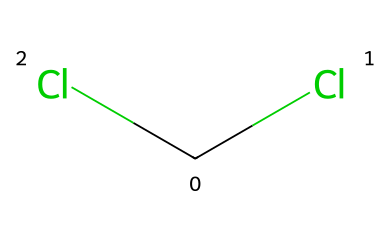How many chlorine atoms are present in the chemical? Inspecting the SMILES representation (C(Cl)(Cl)), we can see that the central carbon atom (C) is bonded to two chlorine atoms (Cl). Each "Cl" in the representation indicates a chlorine atom directly attached to the carbon. Therefore, there are two chlorine atoms.
Answer: 2 What type of bonding exists between the chlorine atoms and the carbon atom? The structure indicates that the carbon atom is bonded to two chlorine atoms. In SMILES, the parentheses indicate single bonds. Hence, the bonding between the carbon and each chlorine atom is single covalent bonding.
Answer: single covalent Is this compound a stable carbene? The compound has two chlorine atoms attached to a carbon, suggesting it is not a free carbene which would typically have a carbene structure with two empty p-orbitals and be less stable. Stability is reduced due to the presence of electronegative chlorine atoms, which withdraw electrons.
Answer: no What is the hybridization of the central carbon atom? The central carbon atom in the compound has three substituents: two Cl atoms and one hydrogen atom (though hydrogen isn't shown in this representation). Based on VSEPR theory, with three substituents and no lone pairs, the hybridization of this carbon atom is sp².
Answer: sp² Could this compound participate in a carbene reaction? Since this structure is not a free carbene but a chlorinated structure, it does not possess the necessary empty p-orbitals characteristic of carbene intermediates necessary for typical carbene reactions, such as insertion or cyclopropanation.
Answer: no What kind of transformation might this compound undergo when decomposing household cleaners? Given that the compound has chlorine substituents, it could undergo elimination or substitution reactions leading to the release of toxic gases like chlorine. This transformation is typical of compounds with halogens in cleaning products.
Answer: elimination or substitution 